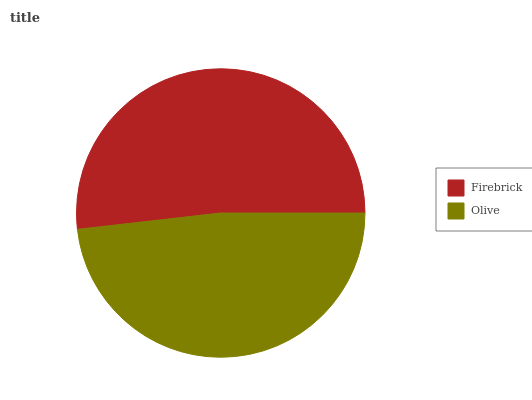Is Olive the minimum?
Answer yes or no. Yes. Is Firebrick the maximum?
Answer yes or no. Yes. Is Olive the maximum?
Answer yes or no. No. Is Firebrick greater than Olive?
Answer yes or no. Yes. Is Olive less than Firebrick?
Answer yes or no. Yes. Is Olive greater than Firebrick?
Answer yes or no. No. Is Firebrick less than Olive?
Answer yes or no. No. Is Firebrick the high median?
Answer yes or no. Yes. Is Olive the low median?
Answer yes or no. Yes. Is Olive the high median?
Answer yes or no. No. Is Firebrick the low median?
Answer yes or no. No. 